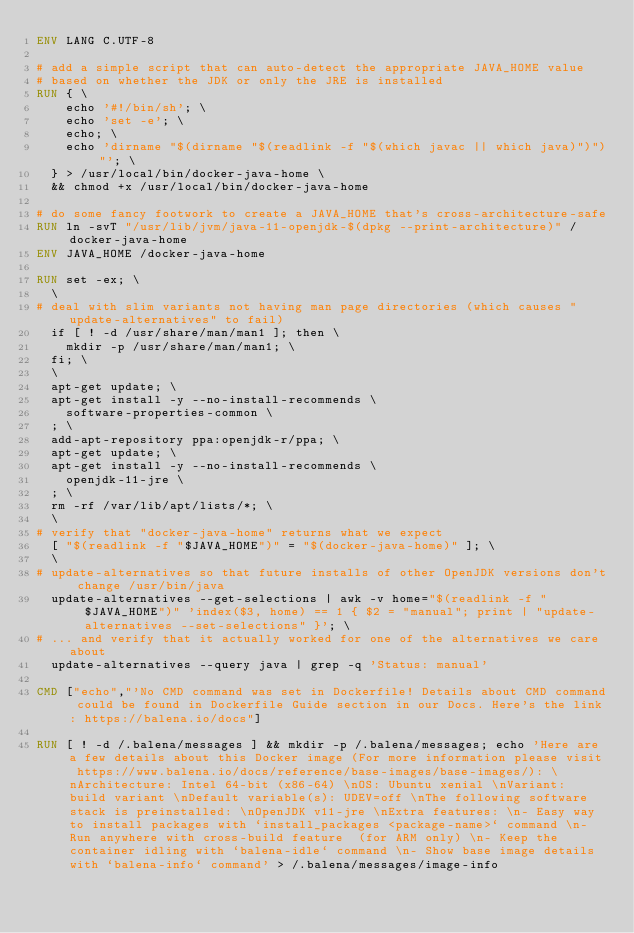<code> <loc_0><loc_0><loc_500><loc_500><_Dockerfile_>ENV LANG C.UTF-8

# add a simple script that can auto-detect the appropriate JAVA_HOME value
# based on whether the JDK or only the JRE is installed
RUN { \
		echo '#!/bin/sh'; \
		echo 'set -e'; \
		echo; \
		echo 'dirname "$(dirname "$(readlink -f "$(which javac || which java)")")"'; \
	} > /usr/local/bin/docker-java-home \
	&& chmod +x /usr/local/bin/docker-java-home

# do some fancy footwork to create a JAVA_HOME that's cross-architecture-safe
RUN ln -svT "/usr/lib/jvm/java-11-openjdk-$(dpkg --print-architecture)" /docker-java-home
ENV JAVA_HOME /docker-java-home

RUN set -ex; \
	\
# deal with slim variants not having man page directories (which causes "update-alternatives" to fail)
	if [ ! -d /usr/share/man/man1 ]; then \
		mkdir -p /usr/share/man/man1; \
	fi; \
	\
	apt-get update; \
	apt-get install -y --no-install-recommends \
		software-properties-common \
	; \
	add-apt-repository ppa:openjdk-r/ppa; \
	apt-get update; \
	apt-get install -y --no-install-recommends \
		openjdk-11-jre \
	; \
	rm -rf /var/lib/apt/lists/*; \
	\
# verify that "docker-java-home" returns what we expect
	[ "$(readlink -f "$JAVA_HOME")" = "$(docker-java-home)" ]; \
	\
# update-alternatives so that future installs of other OpenJDK versions don't change /usr/bin/java
	update-alternatives --get-selections | awk -v home="$(readlink -f "$JAVA_HOME")" 'index($3, home) == 1 { $2 = "manual"; print | "update-alternatives --set-selections" }'; \
# ... and verify that it actually worked for one of the alternatives we care about
	update-alternatives --query java | grep -q 'Status: manual'

CMD ["echo","'No CMD command was set in Dockerfile! Details about CMD command could be found in Dockerfile Guide section in our Docs. Here's the link: https://balena.io/docs"]

RUN [ ! -d /.balena/messages ] && mkdir -p /.balena/messages; echo 'Here are a few details about this Docker image (For more information please visit https://www.balena.io/docs/reference/base-images/base-images/): \nArchitecture: Intel 64-bit (x86-64) \nOS: Ubuntu xenial \nVariant: build variant \nDefault variable(s): UDEV=off \nThe following software stack is preinstalled: \nOpenJDK v11-jre \nExtra features: \n- Easy way to install packages with `install_packages <package-name>` command \n- Run anywhere with cross-build feature  (for ARM only) \n- Keep the container idling with `balena-idle` command \n- Show base image details with `balena-info` command' > /.balena/messages/image-info</code> 